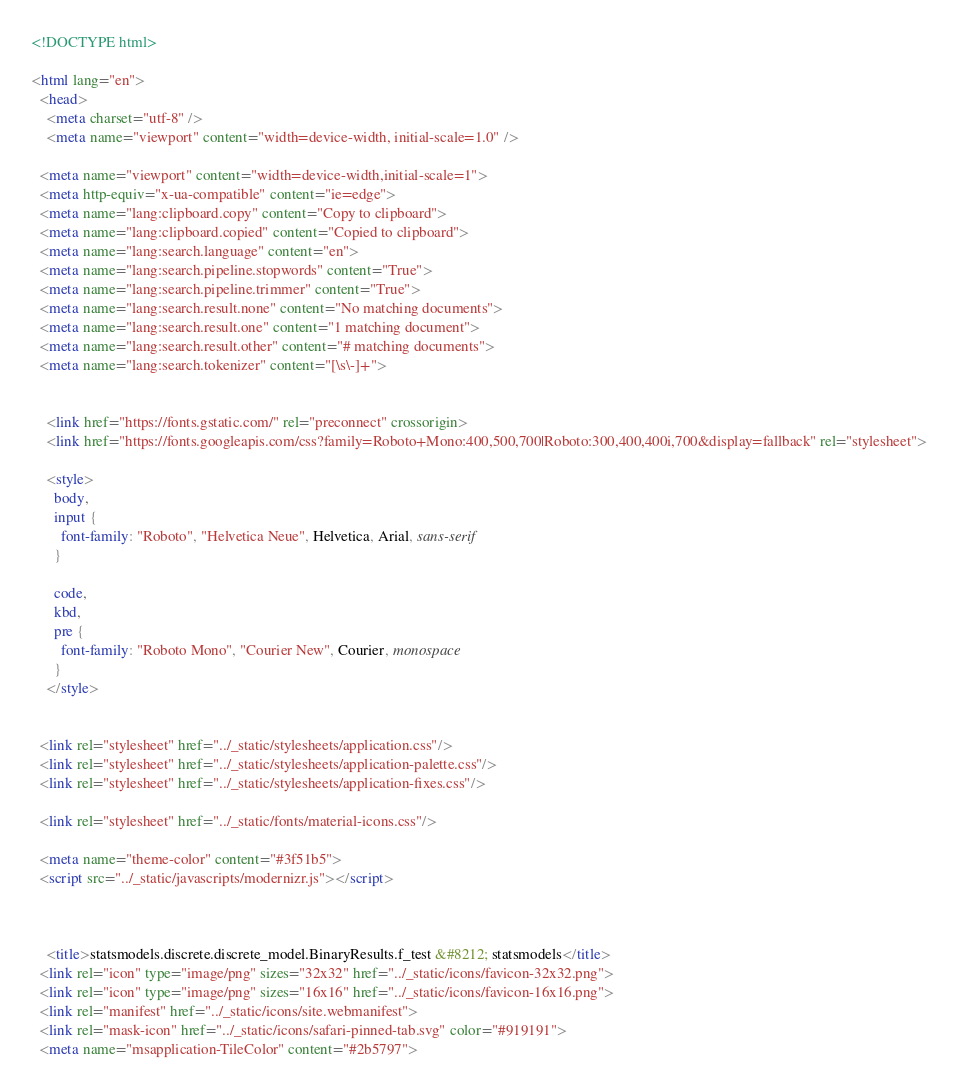<code> <loc_0><loc_0><loc_500><loc_500><_HTML_>

<!DOCTYPE html>

<html lang="en">
  <head>
    <meta charset="utf-8" />
    <meta name="viewport" content="width=device-width, initial-scale=1.0" />
  
  <meta name="viewport" content="width=device-width,initial-scale=1">
  <meta http-equiv="x-ua-compatible" content="ie=edge">
  <meta name="lang:clipboard.copy" content="Copy to clipboard">
  <meta name="lang:clipboard.copied" content="Copied to clipboard">
  <meta name="lang:search.language" content="en">
  <meta name="lang:search.pipeline.stopwords" content="True">
  <meta name="lang:search.pipeline.trimmer" content="True">
  <meta name="lang:search.result.none" content="No matching documents">
  <meta name="lang:search.result.one" content="1 matching document">
  <meta name="lang:search.result.other" content="# matching documents">
  <meta name="lang:search.tokenizer" content="[\s\-]+">

  
    <link href="https://fonts.gstatic.com/" rel="preconnect" crossorigin>
    <link href="https://fonts.googleapis.com/css?family=Roboto+Mono:400,500,700|Roboto:300,400,400i,700&display=fallback" rel="stylesheet">

    <style>
      body,
      input {
        font-family: "Roboto", "Helvetica Neue", Helvetica, Arial, sans-serif
      }

      code,
      kbd,
      pre {
        font-family: "Roboto Mono", "Courier New", Courier, monospace
      }
    </style>
  

  <link rel="stylesheet" href="../_static/stylesheets/application.css"/>
  <link rel="stylesheet" href="../_static/stylesheets/application-palette.css"/>
  <link rel="stylesheet" href="../_static/stylesheets/application-fixes.css"/>
  
  <link rel="stylesheet" href="../_static/fonts/material-icons.css"/>
  
  <meta name="theme-color" content="#3f51b5">
  <script src="../_static/javascripts/modernizr.js"></script>
  
  
  
    <title>statsmodels.discrete.discrete_model.BinaryResults.f_test &#8212; statsmodels</title>
  <link rel="icon" type="image/png" sizes="32x32" href="../_static/icons/favicon-32x32.png">
  <link rel="icon" type="image/png" sizes="16x16" href="../_static/icons/favicon-16x16.png">
  <link rel="manifest" href="../_static/icons/site.webmanifest">
  <link rel="mask-icon" href="../_static/icons/safari-pinned-tab.svg" color="#919191">
  <meta name="msapplication-TileColor" content="#2b5797"></code> 